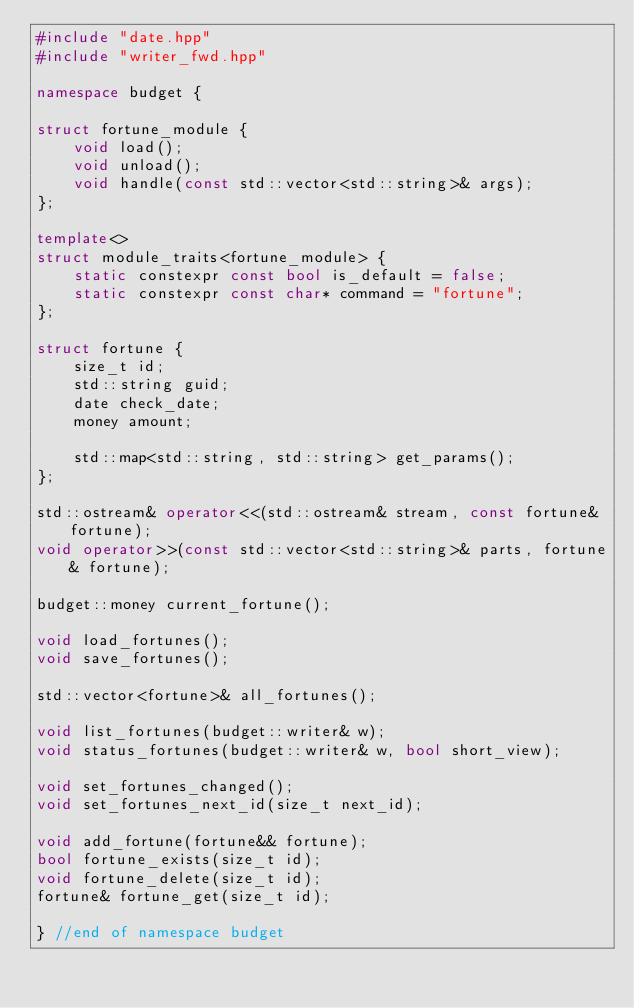Convert code to text. <code><loc_0><loc_0><loc_500><loc_500><_C++_>#include "date.hpp"
#include "writer_fwd.hpp"

namespace budget {

struct fortune_module {
    void load();
    void unload();
    void handle(const std::vector<std::string>& args);
};

template<>
struct module_traits<fortune_module> {
    static constexpr const bool is_default = false;
    static constexpr const char* command = "fortune";
};

struct fortune {
    size_t id;
    std::string guid;
    date check_date;
    money amount;

    std::map<std::string, std::string> get_params();
};

std::ostream& operator<<(std::ostream& stream, const fortune& fortune);
void operator>>(const std::vector<std::string>& parts, fortune& fortune);

budget::money current_fortune();

void load_fortunes();
void save_fortunes();

std::vector<fortune>& all_fortunes();

void list_fortunes(budget::writer& w);
void status_fortunes(budget::writer& w, bool short_view);

void set_fortunes_changed();
void set_fortunes_next_id(size_t next_id);

void add_fortune(fortune&& fortune);
bool fortune_exists(size_t id);
void fortune_delete(size_t id);
fortune& fortune_get(size_t id);

} //end of namespace budget
</code> 